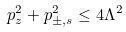Convert formula to latex. <formula><loc_0><loc_0><loc_500><loc_500>p _ { z } ^ { 2 } + p _ { \pm , s } ^ { 2 } \leq 4 \Lambda ^ { 2 }</formula> 